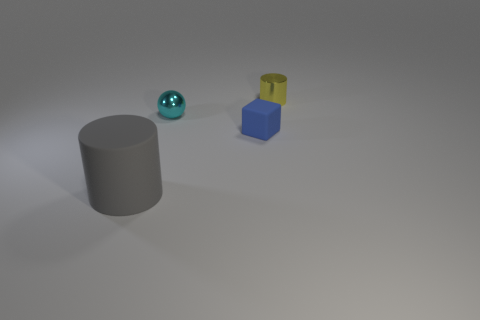Is there anything else that is the same size as the gray cylinder?
Offer a terse response. No. What material is the cylinder in front of the small shiny thing to the left of the shiny object to the right of the ball?
Your response must be concise. Rubber. There is a metal object that is in front of the tiny yellow cylinder; what number of small blue blocks are left of it?
Your response must be concise. 0. What color is the small metallic thing that is the same shape as the big rubber object?
Your response must be concise. Yellow. Are the gray cylinder and the small cube made of the same material?
Ensure brevity in your answer.  Yes. What number of cubes are either tiny yellow things or tiny things?
Provide a short and direct response. 1. How big is the cylinder that is left of the cylinder that is behind the matte thing that is behind the gray cylinder?
Provide a short and direct response. Large. The yellow object that is the same shape as the gray object is what size?
Make the answer very short. Small. There is a tiny ball; how many things are behind it?
Give a very brief answer. 1. What number of yellow things are either metallic cylinders or large matte spheres?
Keep it short and to the point. 1. 